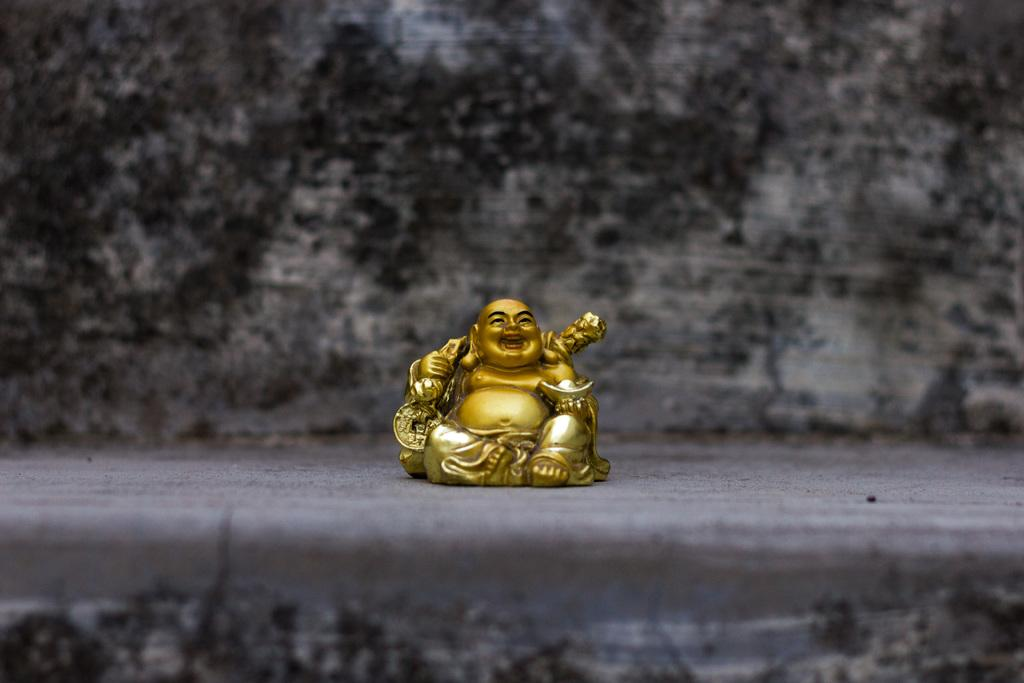What is the main subject in the image? There is a laughing Buddha in the image. How would you describe the background of the image? The background of the image has a blurred view. What part of the image has a similar blurred view? The bottom of the image has a blurred view. What type of neck accessory is the laughing Buddha wearing in the image? The laughing Buddha is not wearing any neck accessory in the image. How many bricks can be seen in the image? There are no bricks present in the image. 